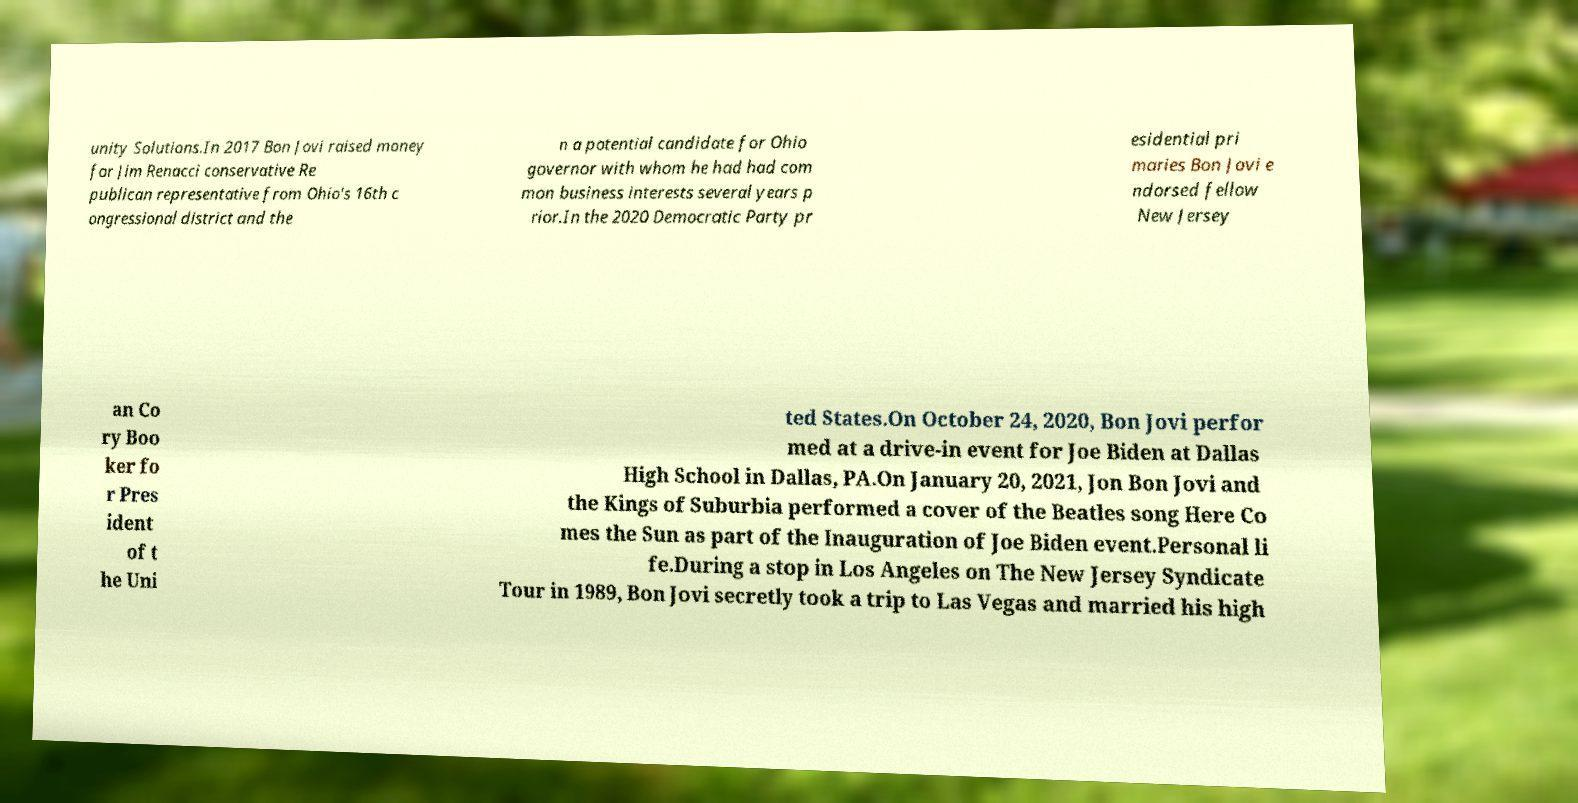Can you read and provide the text displayed in the image?This photo seems to have some interesting text. Can you extract and type it out for me? unity Solutions.In 2017 Bon Jovi raised money for Jim Renacci conservative Re publican representative from Ohio's 16th c ongressional district and the n a potential candidate for Ohio governor with whom he had had com mon business interests several years p rior.In the 2020 Democratic Party pr esidential pri maries Bon Jovi e ndorsed fellow New Jersey an Co ry Boo ker fo r Pres ident of t he Uni ted States.On October 24, 2020, Bon Jovi perfor med at a drive-in event for Joe Biden at Dallas High School in Dallas, PA.On January 20, 2021, Jon Bon Jovi and the Kings of Suburbia performed a cover of the Beatles song Here Co mes the Sun as part of the Inauguration of Joe Biden event.Personal li fe.During a stop in Los Angeles on The New Jersey Syndicate Tour in 1989, Bon Jovi secretly took a trip to Las Vegas and married his high 